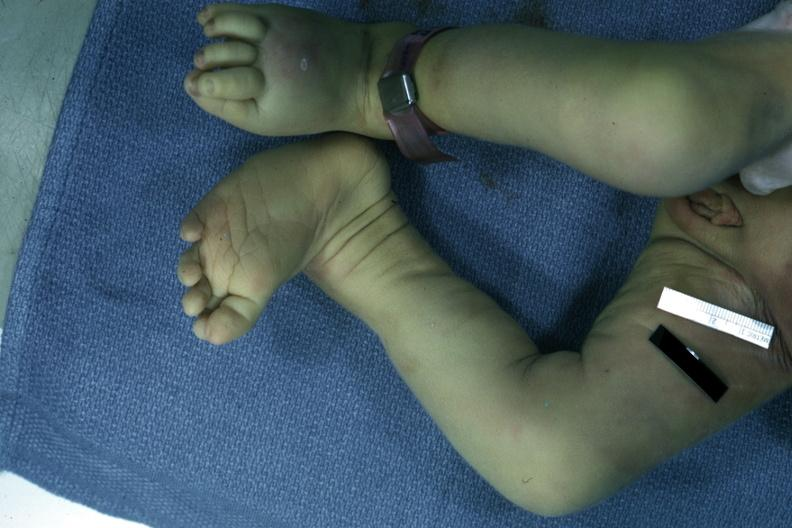s autopsy left club foot?
Answer the question using a single word or phrase. Yes 